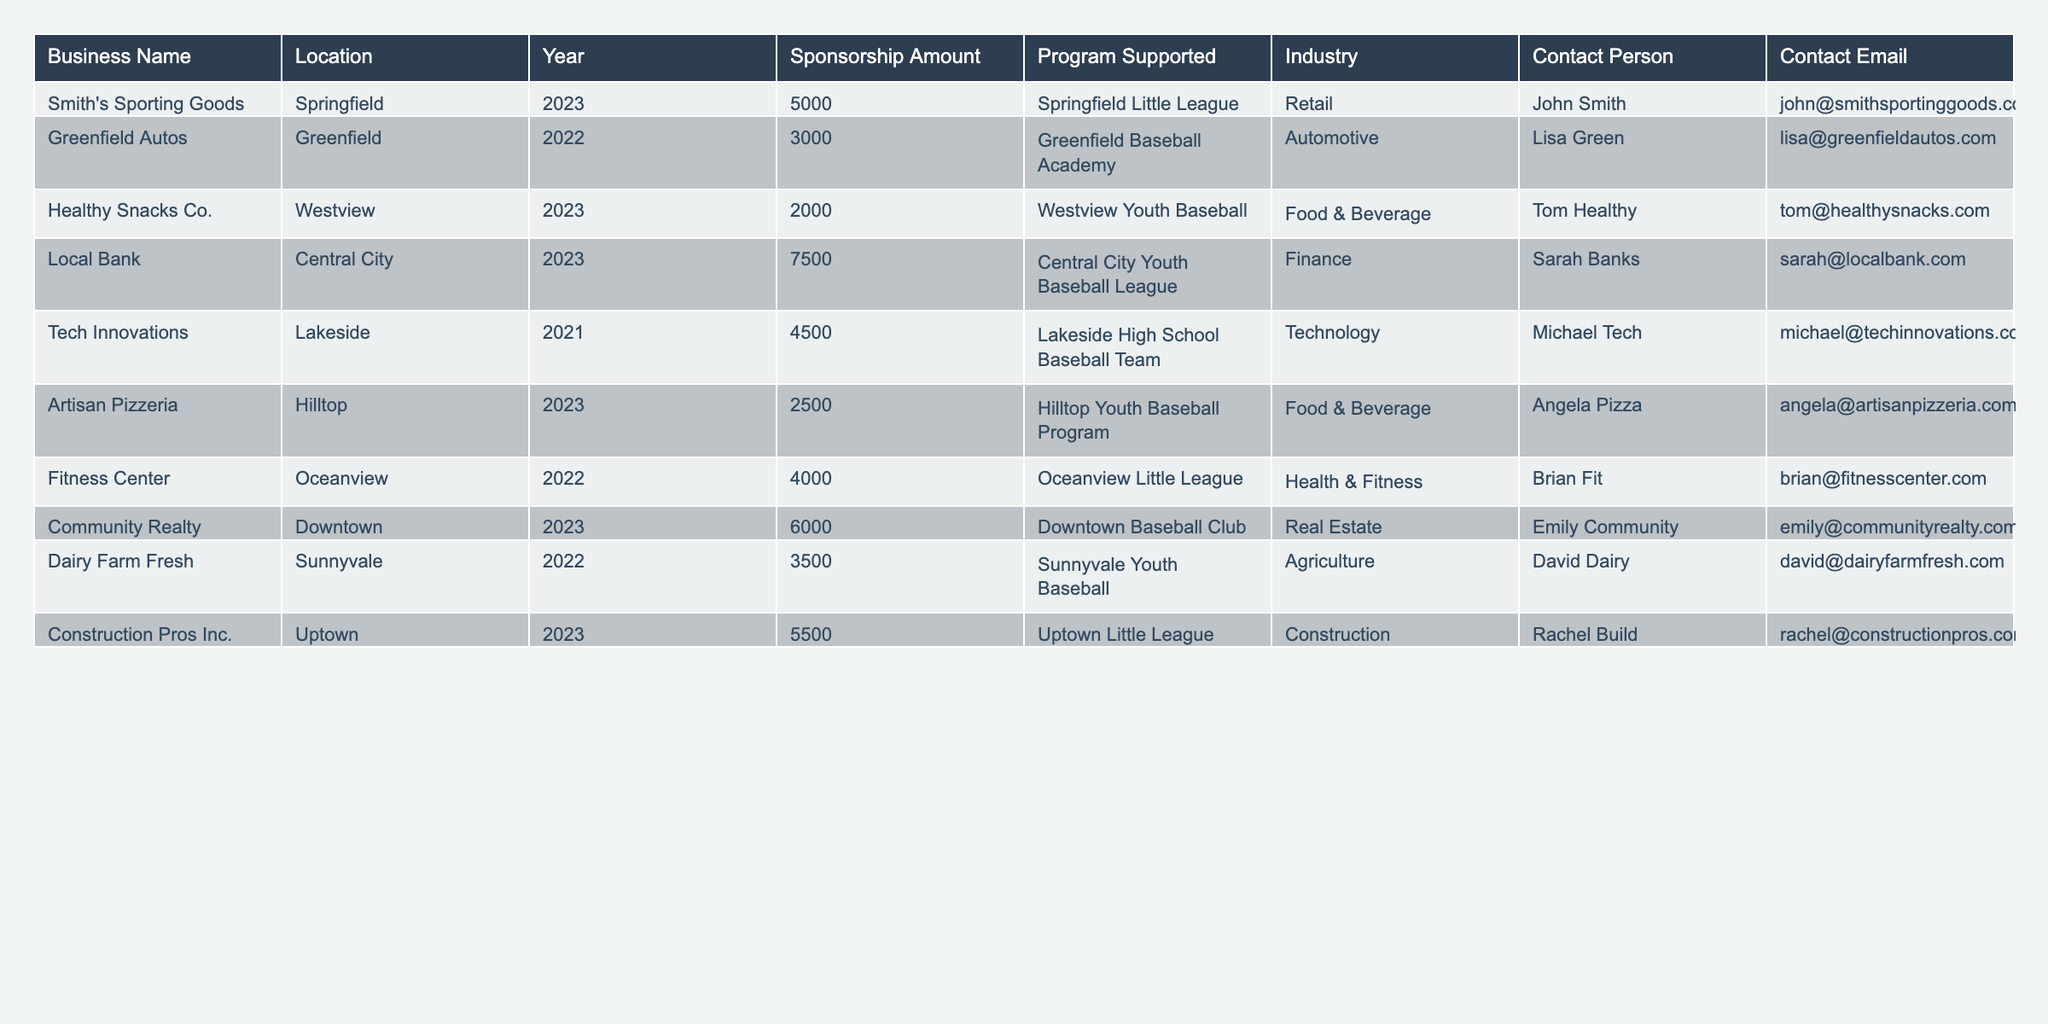What is the total sponsorship amount contributed by the businesses in 2023? To find the total sponsorship amount for 2023, sum the amounts from each relevant row: 5000 (Smith's Sporting Goods) + 2000 (Healthy Snacks Co.) + 7500 (Local Bank) + 6000 (Community Realty) + 5500 (Construction Pros Inc.) = 30000.
Answer: 30000 Which business contributed the highest sponsorship amount in 2022? Looking at the 2022 sponsorship amounts, the contributions are: 3000 (Greenfield Autos), 4000 (Fitness Center), and 3500 (Dairy Farm Fresh). The highest is 4000 from Fitness Center.
Answer: 4000 How many different industries supported youth baseball initiatives in 2023? The industries in 2023 are: Retail (Smith's Sporting Goods), Food & Beverage (Healthy Snacks Co.), Finance (Local Bank), Real Estate (Community Realty), and Construction (Construction Pros Inc.). There are 5 different industries.
Answer: 5 Did Dairy Farm Fresh sponsor a program in 2023? Dairy Farm Fresh's entry shows it sponsored in 2022, not 2023, which means it did not contribute in 2023.
Answer: No What is the average sponsorship amount for all businesses in 2022? The total sponsorship amounts for 2022 are: 3000 (Greenfield Autos) + 4000 (Fitness Center) + 3500 (Dairy Farm Fresh) = 10500. There are 3 businesses, so the average is 10500 / 3 = 3500.
Answer: 3500 Which program received the lowest sponsorship amount, and how much was it? The lowest sponsorship amounts are: 3000 (Greenfield Baseball Academy) and 2000 (Westview Youth Baseball). The lowest amount is 2000 for Westview Youth Baseball.
Answer: 2000 and Westview Youth Baseball What percentage of the total contributions in 2023 came from the Local Bank? The Local Bank contributed 7500, and the total contributions in 2023 are 30000. To find the percentage: (7500 / 30000) * 100 = 25%.
Answer: 25% How many businesses contributed above the average sponsorship amount of 4000 in 2023? In 2023, the amounts are: 5000 (Smith's Sporting Goods), 2000 (Healthy Snacks Co.), 7500 (Local Bank), 6000 (Community Realty), and 5500 (Construction Pros Inc.). The businesses above 4000 are: Local Bank, Community Realty, Construction Pros Inc. Total: 3.
Answer: 3 How many unique contact persons are listed in the table? The contact persons are: John Smith, Lisa Green, Tom Healthy, Sarah Banks, Michael Tech, Angela Pizza, Brian Fit, Emily Community, and David Dairy, totaling 9 unique individuals.
Answer: 9 